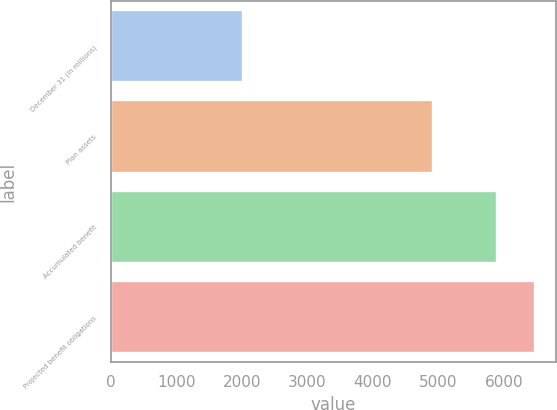Convert chart. <chart><loc_0><loc_0><loc_500><loc_500><bar_chart><fcel>December 31 (In millions)<fcel>Plan assets<fcel>Accumulated benefit<fcel>Projected benefit obligations<nl><fcel>2008<fcel>4914<fcel>5888<fcel>6468<nl></chart> 